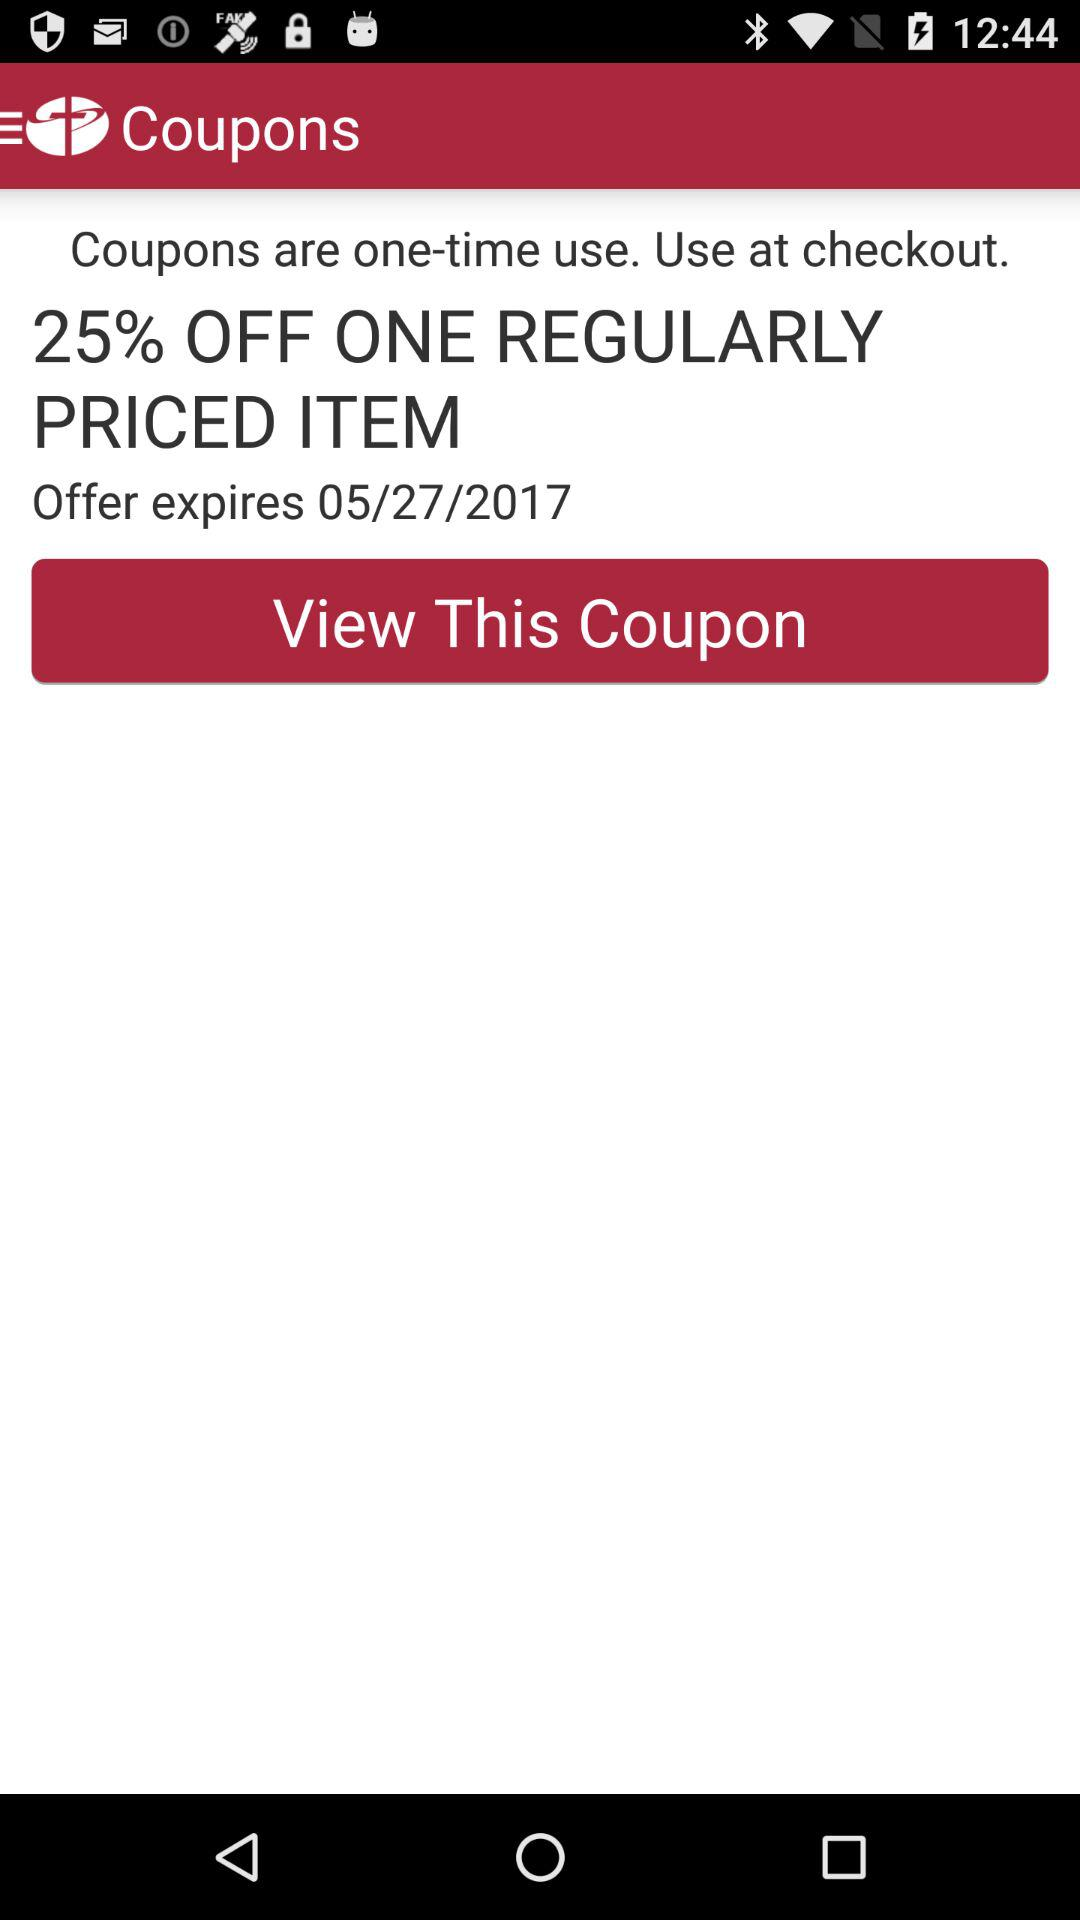How much of a discount is mentioned for one regularly priced item? The discount mentioned for one regularly priced item is 25%. 